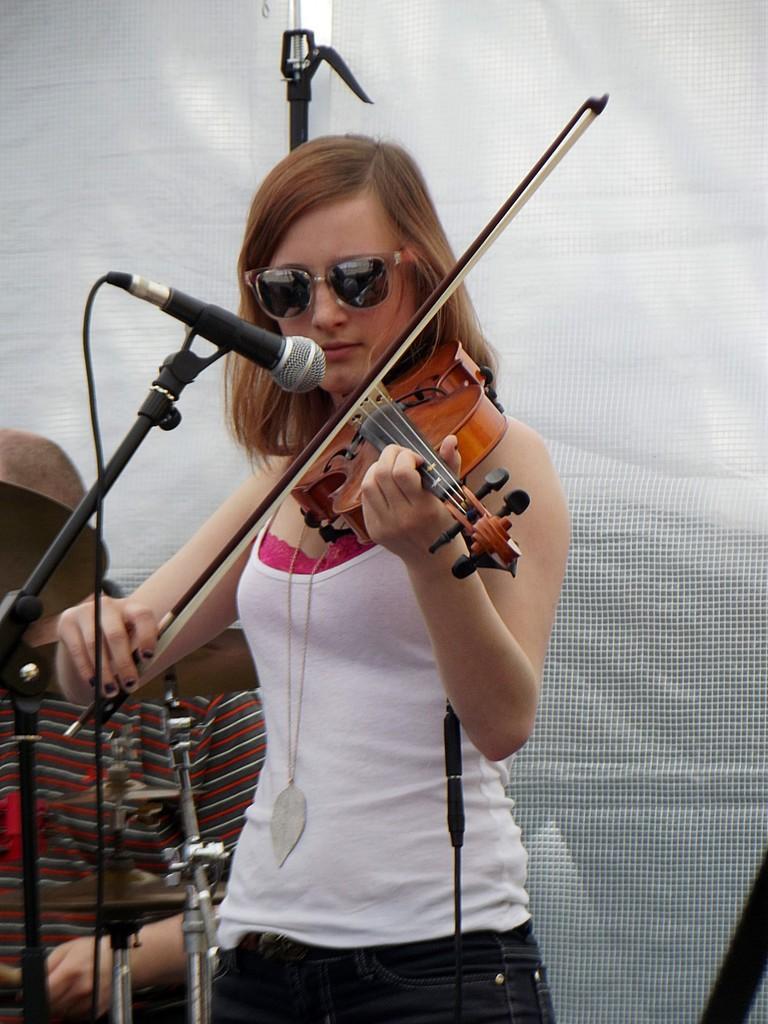In one or two sentences, can you explain what this image depicts? In this image there is a person wearing white color dress playing violin in front of her there is a microphone. 